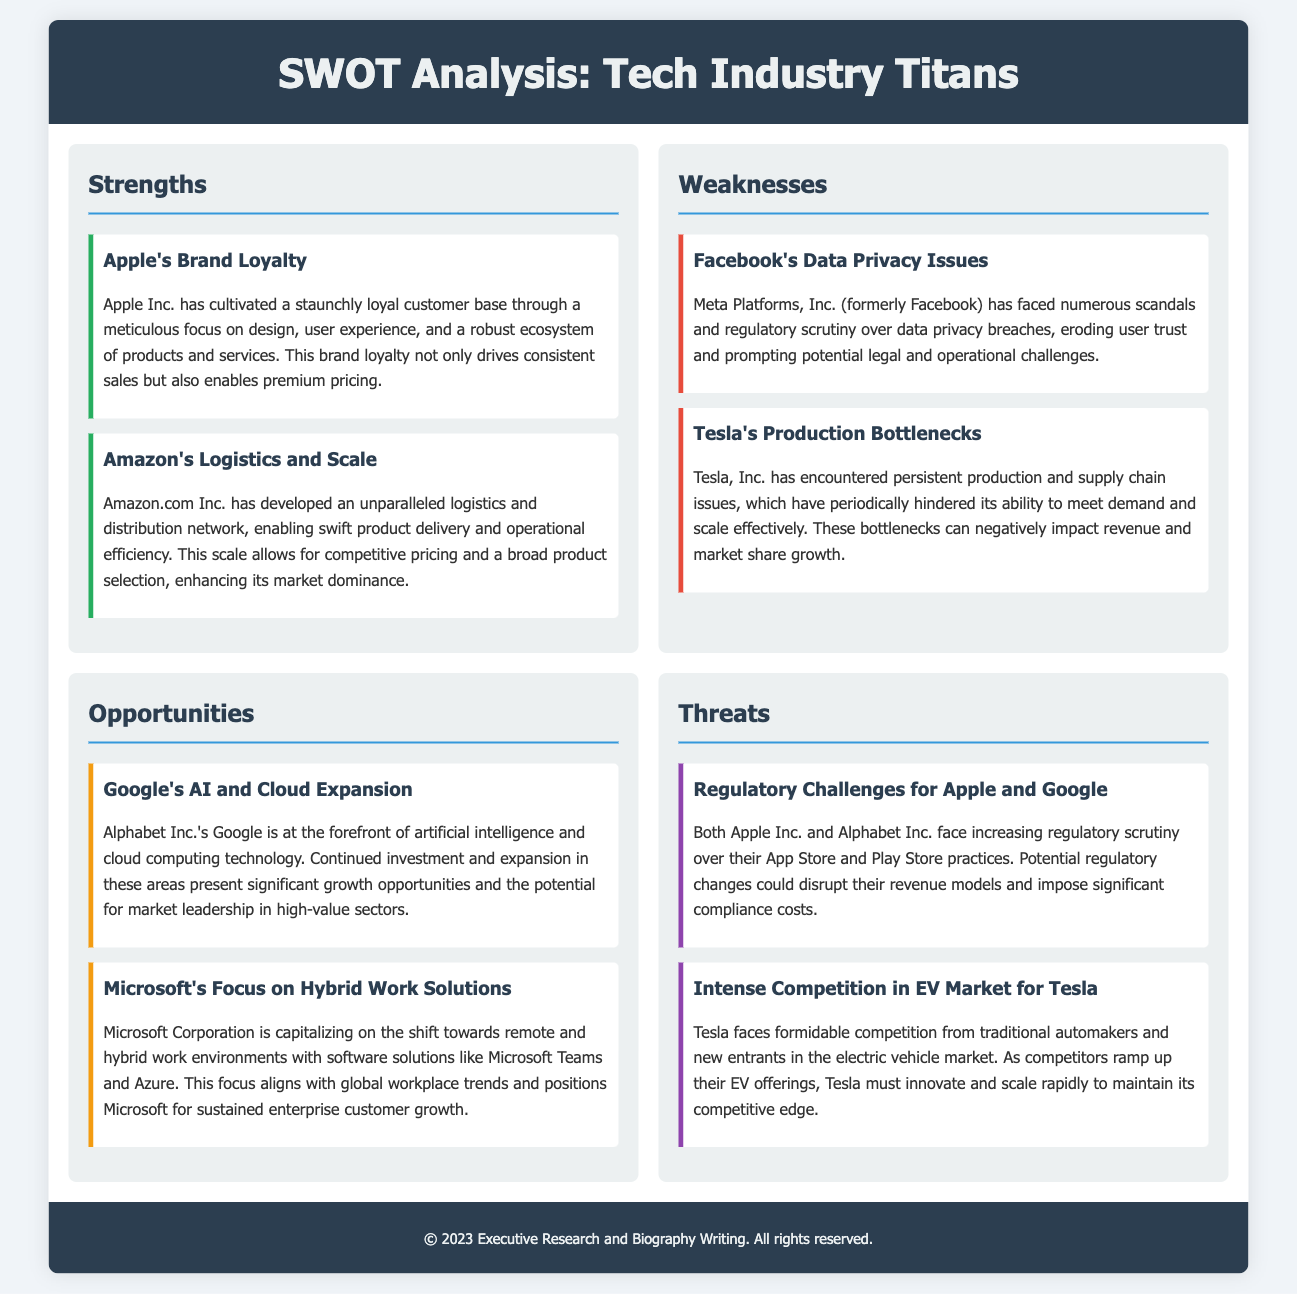What is one of Apple's strengths? Apple's strength includes its brand loyalty, cultivated through design and user experience.
Answer: Brand Loyalty What logistic advantage does Amazon have? Amazon's strength lies in its logistics and distribution network, enabling swift delivery.
Answer: Logistics and Scale What is a weakness faced by Meta Platforms, Inc.? Meta Platforms, Inc. has faced data privacy issues that erode user trust.
Answer: Data Privacy Issues Which opportunity is highlighted for Google? Google has significant growth opportunities in artificial intelligence and cloud computing.
Answer: AI and Cloud Expansion What competitive threat does Tesla face? Tesla faces intense competition in the electric vehicle market.
Answer: Intense Competition What is the primary focus of Microsoft's strategy? Microsoft's strategy focuses on hybrid work solutions, aligning with workplace trends.
Answer: Hybrid Work Solutions What regulatory challenge do Apple and Google share? Both companies face increasing regulatory scrutiny over their app store practices.
Answer: Regulatory Challenges How has Tesla's production been affected? Tesla has encountered production bottlenecks that hinder its ability to scale.
Answer: Production Bottlenecks What drives Amazon's market dominance? Amazon's market dominance is driven by its logistics and scale, enabling competitive pricing.
Answer: Logistics and Scale 